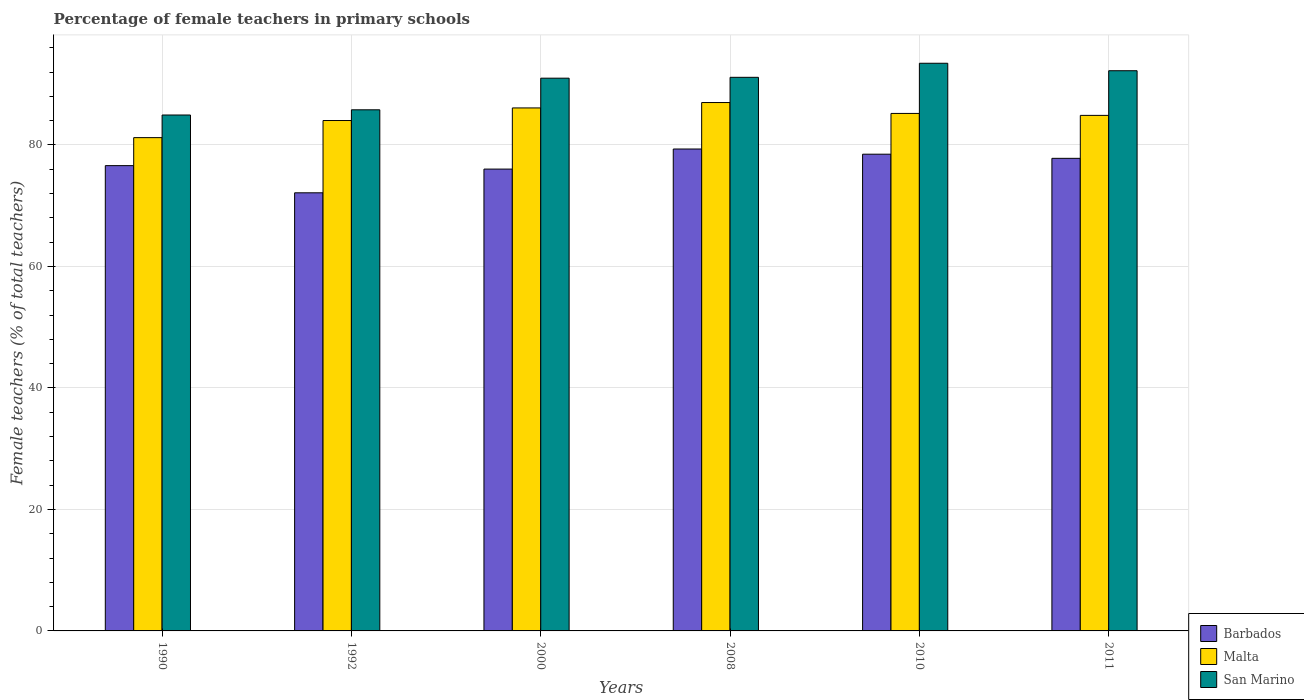How many different coloured bars are there?
Provide a short and direct response. 3. Are the number of bars per tick equal to the number of legend labels?
Offer a very short reply. Yes. Are the number of bars on each tick of the X-axis equal?
Provide a short and direct response. Yes. How many bars are there on the 4th tick from the right?
Provide a succinct answer. 3. In how many cases, is the number of bars for a given year not equal to the number of legend labels?
Offer a very short reply. 0. What is the percentage of female teachers in Malta in 1992?
Give a very brief answer. 84.02. Across all years, what is the maximum percentage of female teachers in Malta?
Make the answer very short. 86.98. Across all years, what is the minimum percentage of female teachers in Malta?
Give a very brief answer. 81.2. In which year was the percentage of female teachers in San Marino minimum?
Ensure brevity in your answer.  1990. What is the total percentage of female teachers in Barbados in the graph?
Offer a very short reply. 460.33. What is the difference between the percentage of female teachers in San Marino in 1990 and that in 2011?
Give a very brief answer. -7.29. What is the difference between the percentage of female teachers in San Marino in 2011 and the percentage of female teachers in Barbados in 2008?
Provide a succinct answer. 12.88. What is the average percentage of female teachers in Malta per year?
Make the answer very short. 84.72. In the year 2008, what is the difference between the percentage of female teachers in Malta and percentage of female teachers in San Marino?
Give a very brief answer. -4.15. In how many years, is the percentage of female teachers in San Marino greater than 4 %?
Offer a terse response. 6. What is the ratio of the percentage of female teachers in San Marino in 2000 to that in 2008?
Your response must be concise. 1. What is the difference between the highest and the second highest percentage of female teachers in Barbados?
Offer a very short reply. 0.86. What is the difference between the highest and the lowest percentage of female teachers in San Marino?
Your answer should be compact. 8.52. In how many years, is the percentage of female teachers in San Marino greater than the average percentage of female teachers in San Marino taken over all years?
Your answer should be compact. 4. What does the 1st bar from the left in 2008 represents?
Provide a short and direct response. Barbados. What does the 3rd bar from the right in 2011 represents?
Your answer should be very brief. Barbados. How many bars are there?
Ensure brevity in your answer.  18. Are all the bars in the graph horizontal?
Give a very brief answer. No. How many legend labels are there?
Provide a succinct answer. 3. What is the title of the graph?
Provide a short and direct response. Percentage of female teachers in primary schools. Does "Lebanon" appear as one of the legend labels in the graph?
Your response must be concise. No. What is the label or title of the X-axis?
Your answer should be compact. Years. What is the label or title of the Y-axis?
Your response must be concise. Female teachers (% of total teachers). What is the Female teachers (% of total teachers) of Barbados in 1990?
Your response must be concise. 76.59. What is the Female teachers (% of total teachers) in Malta in 1990?
Offer a very short reply. 81.2. What is the Female teachers (% of total teachers) in San Marino in 1990?
Provide a succinct answer. 84.92. What is the Female teachers (% of total teachers) of Barbados in 1992?
Offer a very short reply. 72.12. What is the Female teachers (% of total teachers) in Malta in 1992?
Your response must be concise. 84.02. What is the Female teachers (% of total teachers) in San Marino in 1992?
Provide a short and direct response. 85.78. What is the Female teachers (% of total teachers) of Barbados in 2000?
Make the answer very short. 76.02. What is the Female teachers (% of total teachers) in Malta in 2000?
Offer a terse response. 86.09. What is the Female teachers (% of total teachers) of San Marino in 2000?
Provide a succinct answer. 90.99. What is the Female teachers (% of total teachers) in Barbados in 2008?
Offer a very short reply. 79.33. What is the Female teachers (% of total teachers) in Malta in 2008?
Offer a terse response. 86.98. What is the Female teachers (% of total teachers) of San Marino in 2008?
Your answer should be very brief. 91.13. What is the Female teachers (% of total teachers) of Barbados in 2010?
Your answer should be very brief. 78.47. What is the Female teachers (% of total teachers) in Malta in 2010?
Your response must be concise. 85.18. What is the Female teachers (% of total teachers) in San Marino in 2010?
Keep it short and to the point. 93.44. What is the Female teachers (% of total teachers) of Barbados in 2011?
Keep it short and to the point. 77.79. What is the Female teachers (% of total teachers) in Malta in 2011?
Your answer should be compact. 84.86. What is the Female teachers (% of total teachers) of San Marino in 2011?
Give a very brief answer. 92.21. Across all years, what is the maximum Female teachers (% of total teachers) of Barbados?
Offer a very short reply. 79.33. Across all years, what is the maximum Female teachers (% of total teachers) in Malta?
Keep it short and to the point. 86.98. Across all years, what is the maximum Female teachers (% of total teachers) of San Marino?
Your answer should be compact. 93.44. Across all years, what is the minimum Female teachers (% of total teachers) in Barbados?
Provide a short and direct response. 72.12. Across all years, what is the minimum Female teachers (% of total teachers) in Malta?
Offer a terse response. 81.2. Across all years, what is the minimum Female teachers (% of total teachers) in San Marino?
Offer a very short reply. 84.92. What is the total Female teachers (% of total teachers) of Barbados in the graph?
Your response must be concise. 460.33. What is the total Female teachers (% of total teachers) of Malta in the graph?
Your response must be concise. 508.33. What is the total Female teachers (% of total teachers) in San Marino in the graph?
Provide a succinct answer. 538.48. What is the difference between the Female teachers (% of total teachers) in Barbados in 1990 and that in 1992?
Keep it short and to the point. 4.47. What is the difference between the Female teachers (% of total teachers) of Malta in 1990 and that in 1992?
Give a very brief answer. -2.82. What is the difference between the Female teachers (% of total teachers) of San Marino in 1990 and that in 1992?
Keep it short and to the point. -0.86. What is the difference between the Female teachers (% of total teachers) of Barbados in 1990 and that in 2000?
Your answer should be very brief. 0.57. What is the difference between the Female teachers (% of total teachers) of Malta in 1990 and that in 2000?
Offer a terse response. -4.89. What is the difference between the Female teachers (% of total teachers) in San Marino in 1990 and that in 2000?
Offer a terse response. -6.06. What is the difference between the Female teachers (% of total teachers) in Barbados in 1990 and that in 2008?
Offer a very short reply. -2.74. What is the difference between the Female teachers (% of total teachers) of Malta in 1990 and that in 2008?
Your answer should be compact. -5.78. What is the difference between the Female teachers (% of total teachers) of San Marino in 1990 and that in 2008?
Ensure brevity in your answer.  -6.2. What is the difference between the Female teachers (% of total teachers) in Barbados in 1990 and that in 2010?
Provide a short and direct response. -1.88. What is the difference between the Female teachers (% of total teachers) of Malta in 1990 and that in 2010?
Your answer should be very brief. -3.98. What is the difference between the Female teachers (% of total teachers) of San Marino in 1990 and that in 2010?
Keep it short and to the point. -8.52. What is the difference between the Female teachers (% of total teachers) in Barbados in 1990 and that in 2011?
Keep it short and to the point. -1.2. What is the difference between the Female teachers (% of total teachers) of Malta in 1990 and that in 2011?
Your answer should be compact. -3.66. What is the difference between the Female teachers (% of total teachers) in San Marino in 1990 and that in 2011?
Keep it short and to the point. -7.29. What is the difference between the Female teachers (% of total teachers) of Barbados in 1992 and that in 2000?
Ensure brevity in your answer.  -3.9. What is the difference between the Female teachers (% of total teachers) in Malta in 1992 and that in 2000?
Your answer should be very brief. -2.07. What is the difference between the Female teachers (% of total teachers) of San Marino in 1992 and that in 2000?
Your answer should be compact. -5.21. What is the difference between the Female teachers (% of total teachers) in Barbados in 1992 and that in 2008?
Offer a terse response. -7.21. What is the difference between the Female teachers (% of total teachers) in Malta in 1992 and that in 2008?
Make the answer very short. -2.96. What is the difference between the Female teachers (% of total teachers) of San Marino in 1992 and that in 2008?
Keep it short and to the point. -5.35. What is the difference between the Female teachers (% of total teachers) of Barbados in 1992 and that in 2010?
Make the answer very short. -6.35. What is the difference between the Female teachers (% of total teachers) of Malta in 1992 and that in 2010?
Keep it short and to the point. -1.17. What is the difference between the Female teachers (% of total teachers) of San Marino in 1992 and that in 2010?
Offer a terse response. -7.66. What is the difference between the Female teachers (% of total teachers) of Barbados in 1992 and that in 2011?
Your response must be concise. -5.67. What is the difference between the Female teachers (% of total teachers) in Malta in 1992 and that in 2011?
Give a very brief answer. -0.85. What is the difference between the Female teachers (% of total teachers) in San Marino in 1992 and that in 2011?
Offer a very short reply. -6.43. What is the difference between the Female teachers (% of total teachers) of Barbados in 2000 and that in 2008?
Your response must be concise. -3.31. What is the difference between the Female teachers (% of total teachers) in Malta in 2000 and that in 2008?
Offer a very short reply. -0.89. What is the difference between the Female teachers (% of total teachers) of San Marino in 2000 and that in 2008?
Your answer should be compact. -0.14. What is the difference between the Female teachers (% of total teachers) in Barbados in 2000 and that in 2010?
Your response must be concise. -2.45. What is the difference between the Female teachers (% of total teachers) of Malta in 2000 and that in 2010?
Give a very brief answer. 0.91. What is the difference between the Female teachers (% of total teachers) in San Marino in 2000 and that in 2010?
Ensure brevity in your answer.  -2.46. What is the difference between the Female teachers (% of total teachers) in Barbados in 2000 and that in 2011?
Keep it short and to the point. -1.77. What is the difference between the Female teachers (% of total teachers) in Malta in 2000 and that in 2011?
Provide a short and direct response. 1.23. What is the difference between the Female teachers (% of total teachers) of San Marino in 2000 and that in 2011?
Give a very brief answer. -1.23. What is the difference between the Female teachers (% of total teachers) in Barbados in 2008 and that in 2010?
Offer a very short reply. 0.86. What is the difference between the Female teachers (% of total teachers) in Malta in 2008 and that in 2010?
Your response must be concise. 1.79. What is the difference between the Female teachers (% of total teachers) of San Marino in 2008 and that in 2010?
Provide a short and direct response. -2.31. What is the difference between the Female teachers (% of total teachers) in Barbados in 2008 and that in 2011?
Ensure brevity in your answer.  1.54. What is the difference between the Female teachers (% of total teachers) of Malta in 2008 and that in 2011?
Your response must be concise. 2.12. What is the difference between the Female teachers (% of total teachers) of San Marino in 2008 and that in 2011?
Your answer should be very brief. -1.08. What is the difference between the Female teachers (% of total teachers) in Barbados in 2010 and that in 2011?
Give a very brief answer. 0.68. What is the difference between the Female teachers (% of total teachers) of Malta in 2010 and that in 2011?
Provide a short and direct response. 0.32. What is the difference between the Female teachers (% of total teachers) of San Marino in 2010 and that in 2011?
Ensure brevity in your answer.  1.23. What is the difference between the Female teachers (% of total teachers) in Barbados in 1990 and the Female teachers (% of total teachers) in Malta in 1992?
Provide a succinct answer. -7.42. What is the difference between the Female teachers (% of total teachers) of Barbados in 1990 and the Female teachers (% of total teachers) of San Marino in 1992?
Provide a succinct answer. -9.19. What is the difference between the Female teachers (% of total teachers) of Malta in 1990 and the Female teachers (% of total teachers) of San Marino in 1992?
Your answer should be very brief. -4.58. What is the difference between the Female teachers (% of total teachers) in Barbados in 1990 and the Female teachers (% of total teachers) in Malta in 2000?
Make the answer very short. -9.5. What is the difference between the Female teachers (% of total teachers) in Barbados in 1990 and the Female teachers (% of total teachers) in San Marino in 2000?
Your answer should be compact. -14.4. What is the difference between the Female teachers (% of total teachers) in Malta in 1990 and the Female teachers (% of total teachers) in San Marino in 2000?
Your response must be concise. -9.79. What is the difference between the Female teachers (% of total teachers) of Barbados in 1990 and the Female teachers (% of total teachers) of Malta in 2008?
Make the answer very short. -10.38. What is the difference between the Female teachers (% of total teachers) of Barbados in 1990 and the Female teachers (% of total teachers) of San Marino in 2008?
Ensure brevity in your answer.  -14.54. What is the difference between the Female teachers (% of total teachers) of Malta in 1990 and the Female teachers (% of total teachers) of San Marino in 2008?
Offer a terse response. -9.93. What is the difference between the Female teachers (% of total teachers) of Barbados in 1990 and the Female teachers (% of total teachers) of Malta in 2010?
Ensure brevity in your answer.  -8.59. What is the difference between the Female teachers (% of total teachers) of Barbados in 1990 and the Female teachers (% of total teachers) of San Marino in 2010?
Give a very brief answer. -16.85. What is the difference between the Female teachers (% of total teachers) of Malta in 1990 and the Female teachers (% of total teachers) of San Marino in 2010?
Your answer should be compact. -12.24. What is the difference between the Female teachers (% of total teachers) of Barbados in 1990 and the Female teachers (% of total teachers) of Malta in 2011?
Your response must be concise. -8.27. What is the difference between the Female teachers (% of total teachers) of Barbados in 1990 and the Female teachers (% of total teachers) of San Marino in 2011?
Provide a short and direct response. -15.62. What is the difference between the Female teachers (% of total teachers) of Malta in 1990 and the Female teachers (% of total teachers) of San Marino in 2011?
Your answer should be very brief. -11.01. What is the difference between the Female teachers (% of total teachers) in Barbados in 1992 and the Female teachers (% of total teachers) in Malta in 2000?
Make the answer very short. -13.97. What is the difference between the Female teachers (% of total teachers) in Barbados in 1992 and the Female teachers (% of total teachers) in San Marino in 2000?
Offer a terse response. -18.87. What is the difference between the Female teachers (% of total teachers) in Malta in 1992 and the Female teachers (% of total teachers) in San Marino in 2000?
Your answer should be compact. -6.97. What is the difference between the Female teachers (% of total teachers) of Barbados in 1992 and the Female teachers (% of total teachers) of Malta in 2008?
Provide a succinct answer. -14.86. What is the difference between the Female teachers (% of total teachers) of Barbados in 1992 and the Female teachers (% of total teachers) of San Marino in 2008?
Ensure brevity in your answer.  -19.01. What is the difference between the Female teachers (% of total teachers) in Malta in 1992 and the Female teachers (% of total teachers) in San Marino in 2008?
Give a very brief answer. -7.11. What is the difference between the Female teachers (% of total teachers) of Barbados in 1992 and the Female teachers (% of total teachers) of Malta in 2010?
Offer a terse response. -13.06. What is the difference between the Female teachers (% of total teachers) of Barbados in 1992 and the Female teachers (% of total teachers) of San Marino in 2010?
Your answer should be very brief. -21.32. What is the difference between the Female teachers (% of total teachers) of Malta in 1992 and the Female teachers (% of total teachers) of San Marino in 2010?
Give a very brief answer. -9.43. What is the difference between the Female teachers (% of total teachers) in Barbados in 1992 and the Female teachers (% of total teachers) in Malta in 2011?
Your answer should be compact. -12.74. What is the difference between the Female teachers (% of total teachers) of Barbados in 1992 and the Female teachers (% of total teachers) of San Marino in 2011?
Offer a terse response. -20.09. What is the difference between the Female teachers (% of total teachers) of Malta in 1992 and the Female teachers (% of total teachers) of San Marino in 2011?
Your answer should be compact. -8.2. What is the difference between the Female teachers (% of total teachers) in Barbados in 2000 and the Female teachers (% of total teachers) in Malta in 2008?
Your response must be concise. -10.95. What is the difference between the Female teachers (% of total teachers) of Barbados in 2000 and the Female teachers (% of total teachers) of San Marino in 2008?
Provide a short and direct response. -15.11. What is the difference between the Female teachers (% of total teachers) in Malta in 2000 and the Female teachers (% of total teachers) in San Marino in 2008?
Your answer should be very brief. -5.04. What is the difference between the Female teachers (% of total teachers) in Barbados in 2000 and the Female teachers (% of total teachers) in Malta in 2010?
Ensure brevity in your answer.  -9.16. What is the difference between the Female teachers (% of total teachers) in Barbados in 2000 and the Female teachers (% of total teachers) in San Marino in 2010?
Provide a short and direct response. -17.42. What is the difference between the Female teachers (% of total teachers) in Malta in 2000 and the Female teachers (% of total teachers) in San Marino in 2010?
Your answer should be compact. -7.35. What is the difference between the Female teachers (% of total teachers) in Barbados in 2000 and the Female teachers (% of total teachers) in Malta in 2011?
Offer a very short reply. -8.84. What is the difference between the Female teachers (% of total teachers) of Barbados in 2000 and the Female teachers (% of total teachers) of San Marino in 2011?
Keep it short and to the point. -16.19. What is the difference between the Female teachers (% of total teachers) in Malta in 2000 and the Female teachers (% of total teachers) in San Marino in 2011?
Ensure brevity in your answer.  -6.12. What is the difference between the Female teachers (% of total teachers) in Barbados in 2008 and the Female teachers (% of total teachers) in Malta in 2010?
Offer a terse response. -5.85. What is the difference between the Female teachers (% of total teachers) of Barbados in 2008 and the Female teachers (% of total teachers) of San Marino in 2010?
Offer a terse response. -14.11. What is the difference between the Female teachers (% of total teachers) of Malta in 2008 and the Female teachers (% of total teachers) of San Marino in 2010?
Provide a short and direct response. -6.47. What is the difference between the Female teachers (% of total teachers) of Barbados in 2008 and the Female teachers (% of total teachers) of Malta in 2011?
Provide a short and direct response. -5.53. What is the difference between the Female teachers (% of total teachers) in Barbados in 2008 and the Female teachers (% of total teachers) in San Marino in 2011?
Provide a short and direct response. -12.88. What is the difference between the Female teachers (% of total teachers) of Malta in 2008 and the Female teachers (% of total teachers) of San Marino in 2011?
Your answer should be compact. -5.24. What is the difference between the Female teachers (% of total teachers) in Barbados in 2010 and the Female teachers (% of total teachers) in Malta in 2011?
Give a very brief answer. -6.39. What is the difference between the Female teachers (% of total teachers) of Barbados in 2010 and the Female teachers (% of total teachers) of San Marino in 2011?
Provide a short and direct response. -13.74. What is the difference between the Female teachers (% of total teachers) of Malta in 2010 and the Female teachers (% of total teachers) of San Marino in 2011?
Give a very brief answer. -7.03. What is the average Female teachers (% of total teachers) of Barbados per year?
Offer a terse response. 76.72. What is the average Female teachers (% of total teachers) of Malta per year?
Provide a succinct answer. 84.72. What is the average Female teachers (% of total teachers) of San Marino per year?
Your answer should be compact. 89.75. In the year 1990, what is the difference between the Female teachers (% of total teachers) in Barbados and Female teachers (% of total teachers) in Malta?
Provide a succinct answer. -4.61. In the year 1990, what is the difference between the Female teachers (% of total teachers) in Barbados and Female teachers (% of total teachers) in San Marino?
Keep it short and to the point. -8.33. In the year 1990, what is the difference between the Female teachers (% of total teachers) in Malta and Female teachers (% of total teachers) in San Marino?
Your response must be concise. -3.73. In the year 1992, what is the difference between the Female teachers (% of total teachers) in Barbados and Female teachers (% of total teachers) in Malta?
Provide a succinct answer. -11.9. In the year 1992, what is the difference between the Female teachers (% of total teachers) of Barbados and Female teachers (% of total teachers) of San Marino?
Your response must be concise. -13.66. In the year 1992, what is the difference between the Female teachers (% of total teachers) in Malta and Female teachers (% of total teachers) in San Marino?
Keep it short and to the point. -1.76. In the year 2000, what is the difference between the Female teachers (% of total teachers) in Barbados and Female teachers (% of total teachers) in Malta?
Offer a very short reply. -10.07. In the year 2000, what is the difference between the Female teachers (% of total teachers) in Barbados and Female teachers (% of total teachers) in San Marino?
Your answer should be very brief. -14.96. In the year 2000, what is the difference between the Female teachers (% of total teachers) of Malta and Female teachers (% of total teachers) of San Marino?
Ensure brevity in your answer.  -4.9. In the year 2008, what is the difference between the Female teachers (% of total teachers) of Barbados and Female teachers (% of total teachers) of Malta?
Ensure brevity in your answer.  -7.65. In the year 2008, what is the difference between the Female teachers (% of total teachers) in Barbados and Female teachers (% of total teachers) in San Marino?
Offer a very short reply. -11.8. In the year 2008, what is the difference between the Female teachers (% of total teachers) of Malta and Female teachers (% of total teachers) of San Marino?
Provide a short and direct response. -4.15. In the year 2010, what is the difference between the Female teachers (% of total teachers) of Barbados and Female teachers (% of total teachers) of Malta?
Offer a terse response. -6.71. In the year 2010, what is the difference between the Female teachers (% of total teachers) of Barbados and Female teachers (% of total teachers) of San Marino?
Your answer should be very brief. -14.97. In the year 2010, what is the difference between the Female teachers (% of total teachers) in Malta and Female teachers (% of total teachers) in San Marino?
Offer a terse response. -8.26. In the year 2011, what is the difference between the Female teachers (% of total teachers) in Barbados and Female teachers (% of total teachers) in Malta?
Make the answer very short. -7.07. In the year 2011, what is the difference between the Female teachers (% of total teachers) in Barbados and Female teachers (% of total teachers) in San Marino?
Provide a succinct answer. -14.42. In the year 2011, what is the difference between the Female teachers (% of total teachers) of Malta and Female teachers (% of total teachers) of San Marino?
Your response must be concise. -7.35. What is the ratio of the Female teachers (% of total teachers) in Barbados in 1990 to that in 1992?
Offer a terse response. 1.06. What is the ratio of the Female teachers (% of total teachers) in Malta in 1990 to that in 1992?
Ensure brevity in your answer.  0.97. What is the ratio of the Female teachers (% of total teachers) in San Marino in 1990 to that in 1992?
Make the answer very short. 0.99. What is the ratio of the Female teachers (% of total teachers) of Barbados in 1990 to that in 2000?
Give a very brief answer. 1.01. What is the ratio of the Female teachers (% of total teachers) in Malta in 1990 to that in 2000?
Your response must be concise. 0.94. What is the ratio of the Female teachers (% of total teachers) of San Marino in 1990 to that in 2000?
Your answer should be compact. 0.93. What is the ratio of the Female teachers (% of total teachers) in Barbados in 1990 to that in 2008?
Your response must be concise. 0.97. What is the ratio of the Female teachers (% of total teachers) in Malta in 1990 to that in 2008?
Provide a succinct answer. 0.93. What is the ratio of the Female teachers (% of total teachers) in San Marino in 1990 to that in 2008?
Provide a succinct answer. 0.93. What is the ratio of the Female teachers (% of total teachers) in Barbados in 1990 to that in 2010?
Your answer should be compact. 0.98. What is the ratio of the Female teachers (% of total teachers) of Malta in 1990 to that in 2010?
Give a very brief answer. 0.95. What is the ratio of the Female teachers (% of total teachers) in San Marino in 1990 to that in 2010?
Provide a short and direct response. 0.91. What is the ratio of the Female teachers (% of total teachers) of Barbados in 1990 to that in 2011?
Provide a succinct answer. 0.98. What is the ratio of the Female teachers (% of total teachers) in Malta in 1990 to that in 2011?
Make the answer very short. 0.96. What is the ratio of the Female teachers (% of total teachers) in San Marino in 1990 to that in 2011?
Offer a very short reply. 0.92. What is the ratio of the Female teachers (% of total teachers) in Barbados in 1992 to that in 2000?
Your response must be concise. 0.95. What is the ratio of the Female teachers (% of total teachers) of Malta in 1992 to that in 2000?
Provide a short and direct response. 0.98. What is the ratio of the Female teachers (% of total teachers) of San Marino in 1992 to that in 2000?
Ensure brevity in your answer.  0.94. What is the ratio of the Female teachers (% of total teachers) of Barbados in 1992 to that in 2008?
Ensure brevity in your answer.  0.91. What is the ratio of the Female teachers (% of total teachers) in Malta in 1992 to that in 2008?
Offer a very short reply. 0.97. What is the ratio of the Female teachers (% of total teachers) of San Marino in 1992 to that in 2008?
Offer a terse response. 0.94. What is the ratio of the Female teachers (% of total teachers) of Barbados in 1992 to that in 2010?
Make the answer very short. 0.92. What is the ratio of the Female teachers (% of total teachers) in Malta in 1992 to that in 2010?
Give a very brief answer. 0.99. What is the ratio of the Female teachers (% of total teachers) of San Marino in 1992 to that in 2010?
Make the answer very short. 0.92. What is the ratio of the Female teachers (% of total teachers) of Barbados in 1992 to that in 2011?
Offer a terse response. 0.93. What is the ratio of the Female teachers (% of total teachers) of San Marino in 1992 to that in 2011?
Provide a short and direct response. 0.93. What is the ratio of the Female teachers (% of total teachers) of Barbados in 2000 to that in 2008?
Make the answer very short. 0.96. What is the ratio of the Female teachers (% of total teachers) in San Marino in 2000 to that in 2008?
Provide a short and direct response. 1. What is the ratio of the Female teachers (% of total teachers) of Barbados in 2000 to that in 2010?
Provide a succinct answer. 0.97. What is the ratio of the Female teachers (% of total teachers) of Malta in 2000 to that in 2010?
Your response must be concise. 1.01. What is the ratio of the Female teachers (% of total teachers) of San Marino in 2000 to that in 2010?
Offer a very short reply. 0.97. What is the ratio of the Female teachers (% of total teachers) in Barbados in 2000 to that in 2011?
Offer a terse response. 0.98. What is the ratio of the Female teachers (% of total teachers) in Malta in 2000 to that in 2011?
Provide a succinct answer. 1.01. What is the ratio of the Female teachers (% of total teachers) in San Marino in 2000 to that in 2011?
Provide a short and direct response. 0.99. What is the ratio of the Female teachers (% of total teachers) of Barbados in 2008 to that in 2010?
Your answer should be compact. 1.01. What is the ratio of the Female teachers (% of total teachers) of Malta in 2008 to that in 2010?
Your response must be concise. 1.02. What is the ratio of the Female teachers (% of total teachers) of San Marino in 2008 to that in 2010?
Your answer should be compact. 0.98. What is the ratio of the Female teachers (% of total teachers) of Barbados in 2008 to that in 2011?
Your answer should be compact. 1.02. What is the ratio of the Female teachers (% of total teachers) in Malta in 2008 to that in 2011?
Offer a very short reply. 1.02. What is the ratio of the Female teachers (% of total teachers) in Barbados in 2010 to that in 2011?
Ensure brevity in your answer.  1.01. What is the ratio of the Female teachers (% of total teachers) in San Marino in 2010 to that in 2011?
Your answer should be very brief. 1.01. What is the difference between the highest and the second highest Female teachers (% of total teachers) of Barbados?
Make the answer very short. 0.86. What is the difference between the highest and the second highest Female teachers (% of total teachers) in Malta?
Give a very brief answer. 0.89. What is the difference between the highest and the second highest Female teachers (% of total teachers) of San Marino?
Offer a terse response. 1.23. What is the difference between the highest and the lowest Female teachers (% of total teachers) of Barbados?
Keep it short and to the point. 7.21. What is the difference between the highest and the lowest Female teachers (% of total teachers) in Malta?
Offer a very short reply. 5.78. What is the difference between the highest and the lowest Female teachers (% of total teachers) in San Marino?
Your response must be concise. 8.52. 